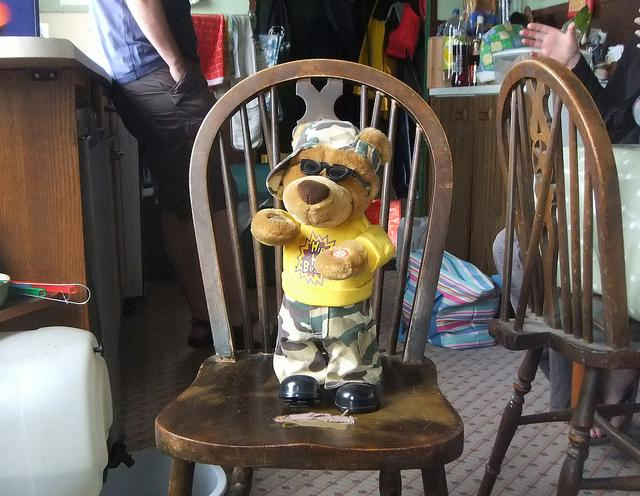What style of pants are these? Please explain your reasoning. camo. Camo pants have a greenish brown pattern. 